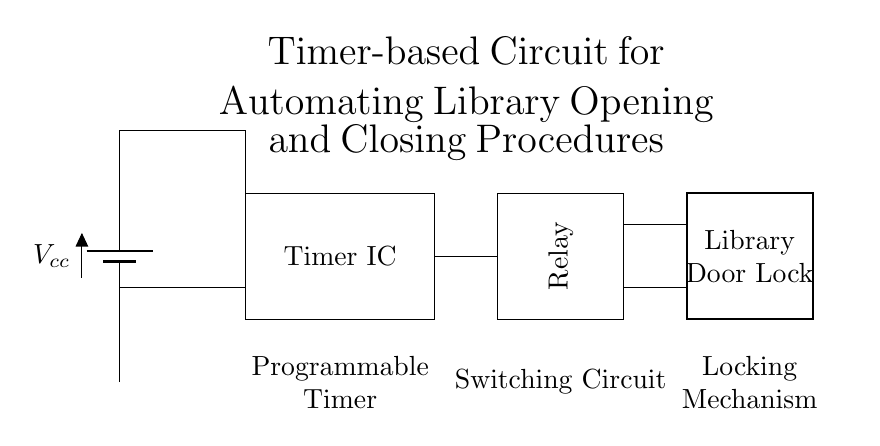What is the power supply used in this circuit? The circuit diagram shows a battery symbol labeled Vcc, indicating that the power supply is a battery providing the necessary voltage for the circuit operation.
Answer: Battery What component is represented by the rectangle labeled "Timer IC"? The rectangle labeled Timer IC signifies the Integrated Circuit responsible for controlling the timing functions of the automation process within the circuit.
Answer: Timer IC What does the relay do in this circuit? The relay acts as a switching device that is activated by the Timer IC to engage or disengage the locking mechanism of the library door, therefore controlling its locking state.
Answer: Switching How many components are connected to the Timer IC? The Timer IC has two connections: one to the power supply and another going to the relay, making the total count of directly connected components equal to two.
Answer: Two What is the function of the library door lock? The library door lock is the final output of the entire timer-based circuit which enables or disables the locking mechanism based on the timer's scheduling, thus securing the library.
Answer: Locking mechanism What is the purpose of the programmable timer in this circuit? The programmable timer is used to set specific times for automatic opening and closing of the library, allowing for scheduled control over when the library is accessible.
Answer: Automation What type of circuit is represented in this diagram? The circuit represented is an automation circuit, specifically designed for scheduled operation of a locking mechanism, useful for facilities management like libraries.
Answer: Automation circuit 